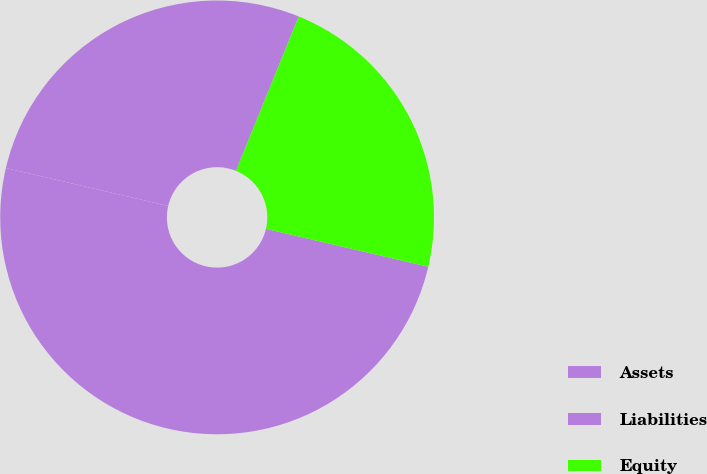Convert chart to OTSL. <chart><loc_0><loc_0><loc_500><loc_500><pie_chart><fcel>Assets<fcel>Liabilities<fcel>Equity<nl><fcel>50.0%<fcel>27.49%<fcel>22.51%<nl></chart> 